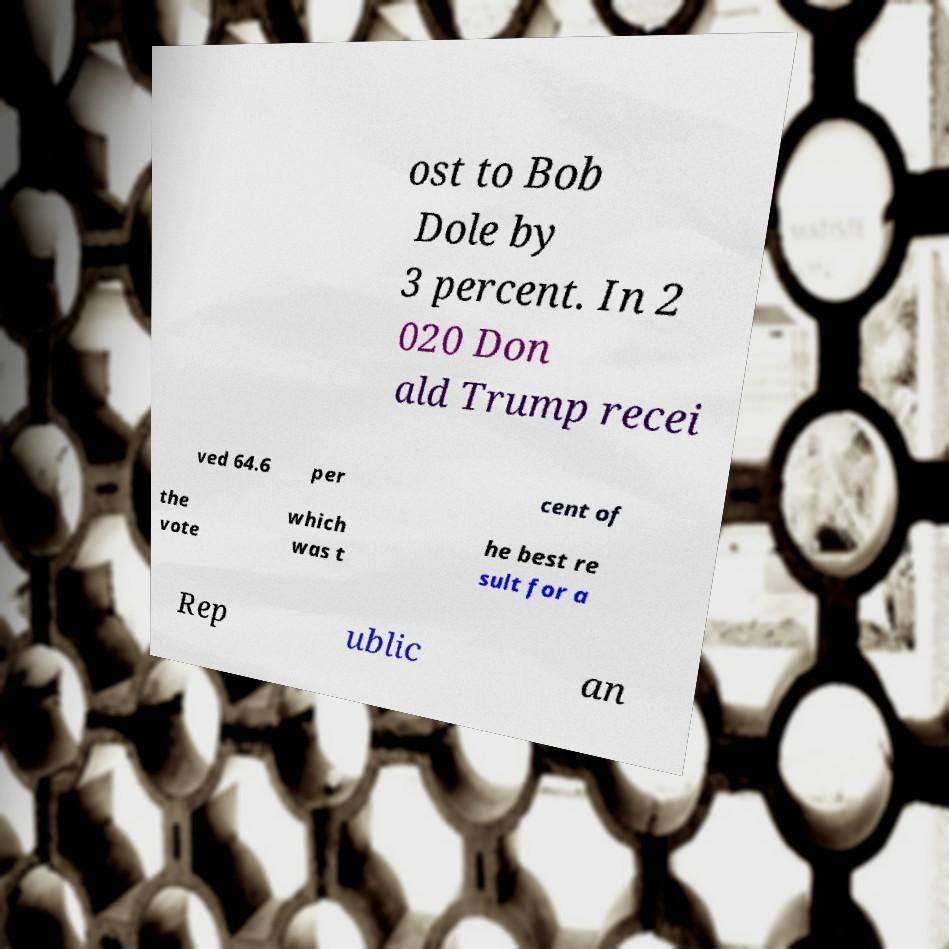Please identify and transcribe the text found in this image. ost to Bob Dole by 3 percent. In 2 020 Don ald Trump recei ved 64.6 per cent of the vote which was t he best re sult for a Rep ublic an 